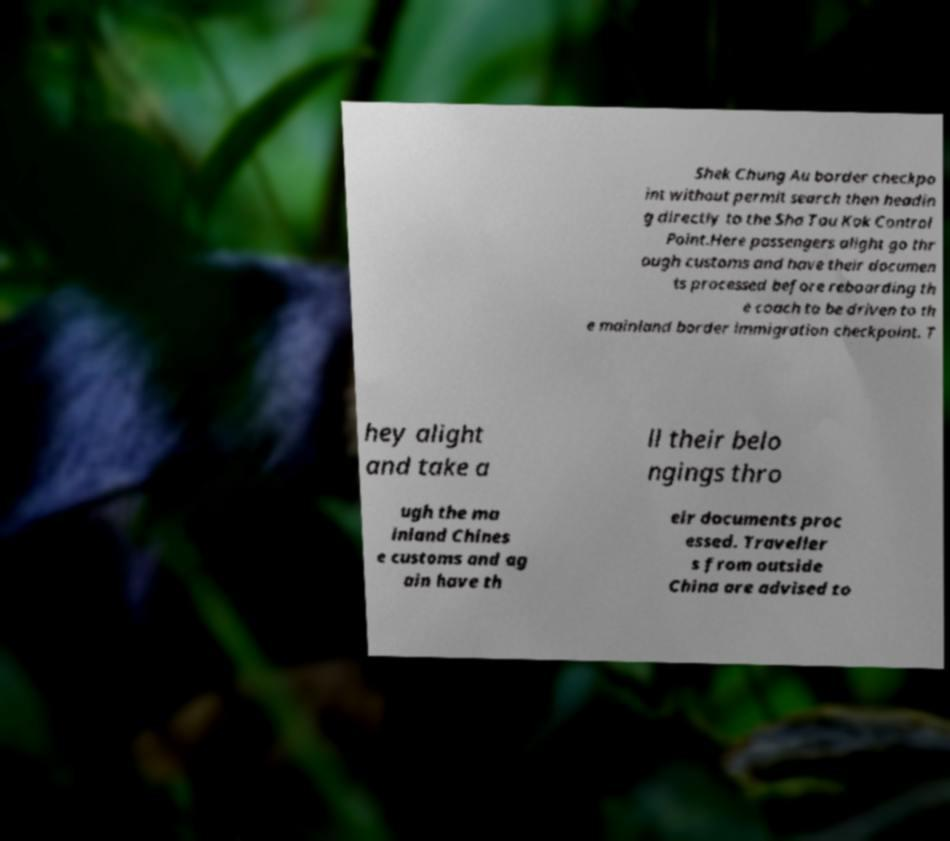Can you accurately transcribe the text from the provided image for me? Shek Chung Au border checkpo int without permit search then headin g directly to the Sha Tau Kok Control Point.Here passengers alight go thr ough customs and have their documen ts processed before reboarding th e coach to be driven to th e mainland border immigration checkpoint. T hey alight and take a ll their belo ngings thro ugh the ma inland Chines e customs and ag ain have th eir documents proc essed. Traveller s from outside China are advised to 